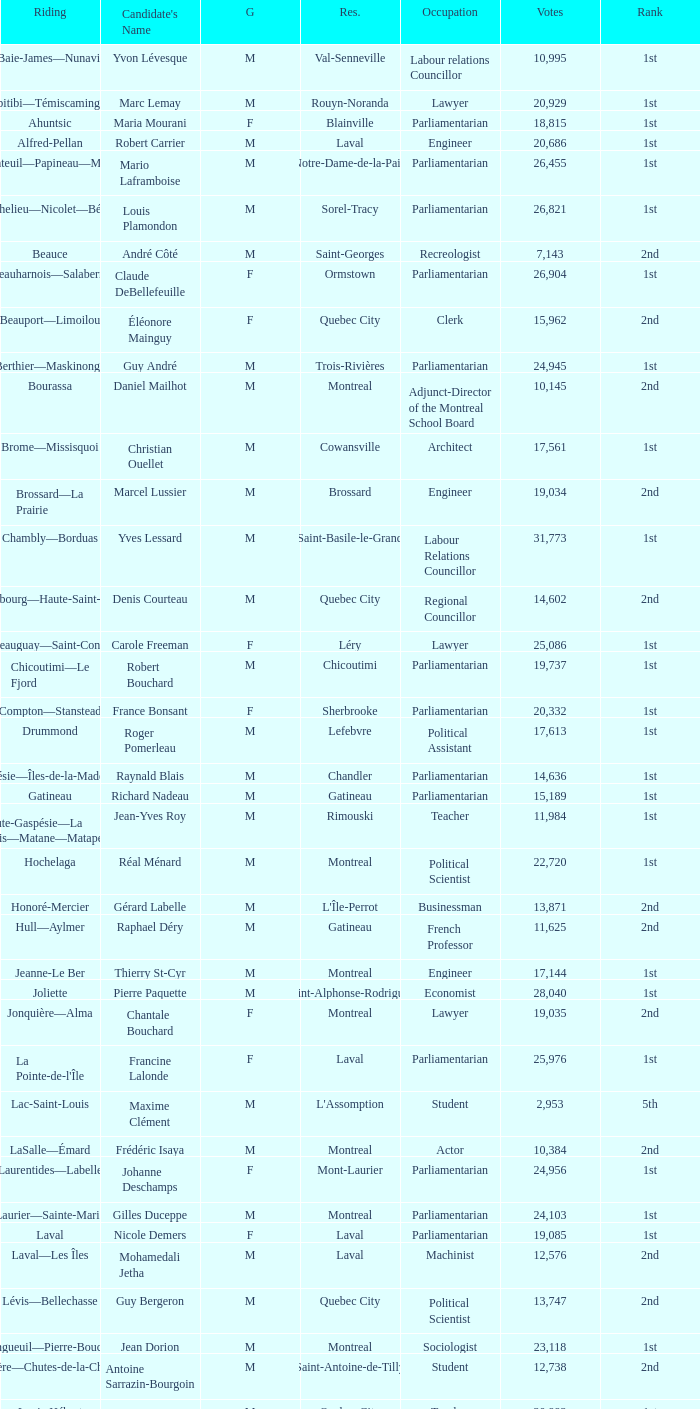What is the highest number of votes for the French Professor? 11625.0. 